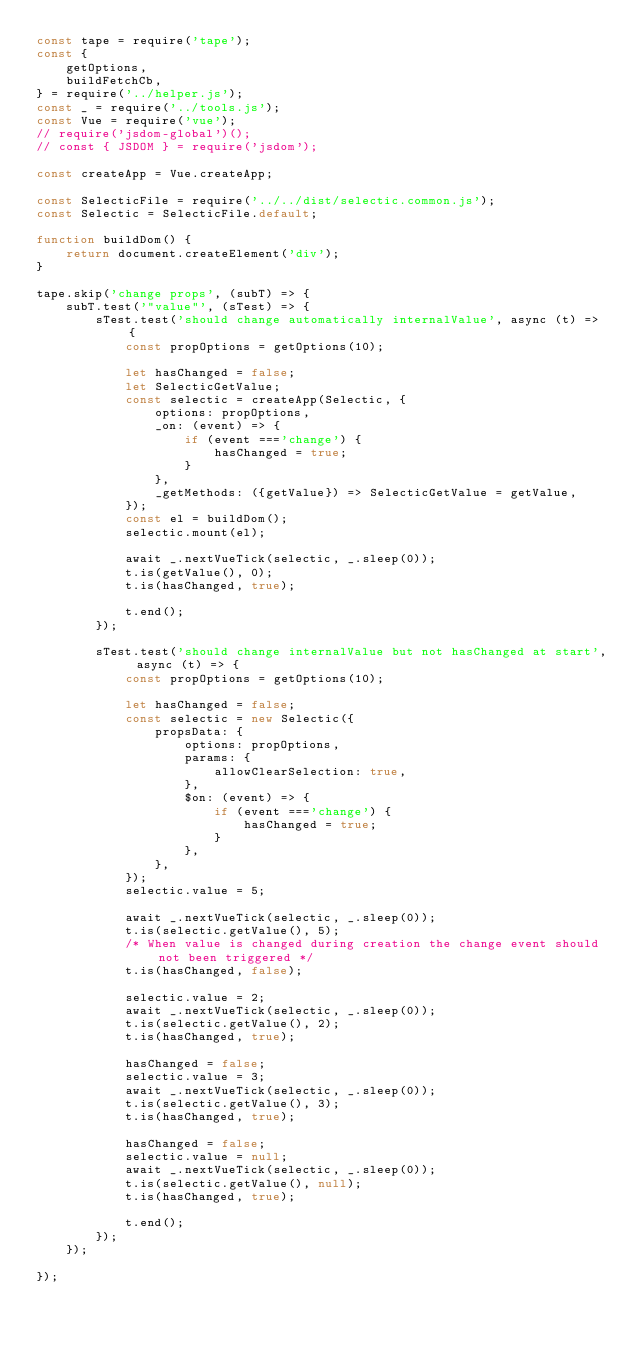<code> <loc_0><loc_0><loc_500><loc_500><_JavaScript_>const tape = require('tape');
const {
    getOptions,
    buildFetchCb,
} = require('../helper.js');
const _ = require('../tools.js');
const Vue = require('vue');
// require('jsdom-global')();
// const { JSDOM } = require('jsdom');

const createApp = Vue.createApp;

const SelecticFile = require('../../dist/selectic.common.js');
const Selectic = SelecticFile.default;

function buildDom() {
    return document.createElement('div');
}

tape.skip('change props', (subT) => {
    subT.test('"value"', (sTest) => {
        sTest.test('should change automatically internalValue', async (t) => {
            const propOptions = getOptions(10);

            let hasChanged = false;
            let SelecticGetValue;
            const selectic = createApp(Selectic, {
                options: propOptions,
                _on: (event) => {
                    if (event ==='change') {
                        hasChanged = true;
                    }
                },
                _getMethods: ({getValue}) => SelecticGetValue = getValue,
            });
            const el = buildDom();
            selectic.mount(el);

            await _.nextVueTick(selectic, _.sleep(0));
            t.is(getValue(), 0);
            t.is(hasChanged, true);

            t.end();
        });

        sTest.test('should change internalValue but not hasChanged at start', async (t) => {
            const propOptions = getOptions(10);

            let hasChanged = false;
            const selectic = new Selectic({
                propsData: {
                    options: propOptions,
                    params: {
                        allowClearSelection: true,
                    },
                    $on: (event) => {
                        if (event ==='change') {
                            hasChanged = true;
                        }
                    },
                },
            });
            selectic.value = 5;

            await _.nextVueTick(selectic, _.sleep(0));
            t.is(selectic.getValue(), 5);
            /* When value is changed during creation the change event should not been triggered */
            t.is(hasChanged, false);

            selectic.value = 2;
            await _.nextVueTick(selectic, _.sleep(0));
            t.is(selectic.getValue(), 2);
            t.is(hasChanged, true);

            hasChanged = false;
            selectic.value = 3;
            await _.nextVueTick(selectic, _.sleep(0));
            t.is(selectic.getValue(), 3);
            t.is(hasChanged, true);

            hasChanged = false;
            selectic.value = null;
            await _.nextVueTick(selectic, _.sleep(0));
            t.is(selectic.getValue(), null);
            t.is(hasChanged, true);

            t.end();
        });
    });

});
</code> 